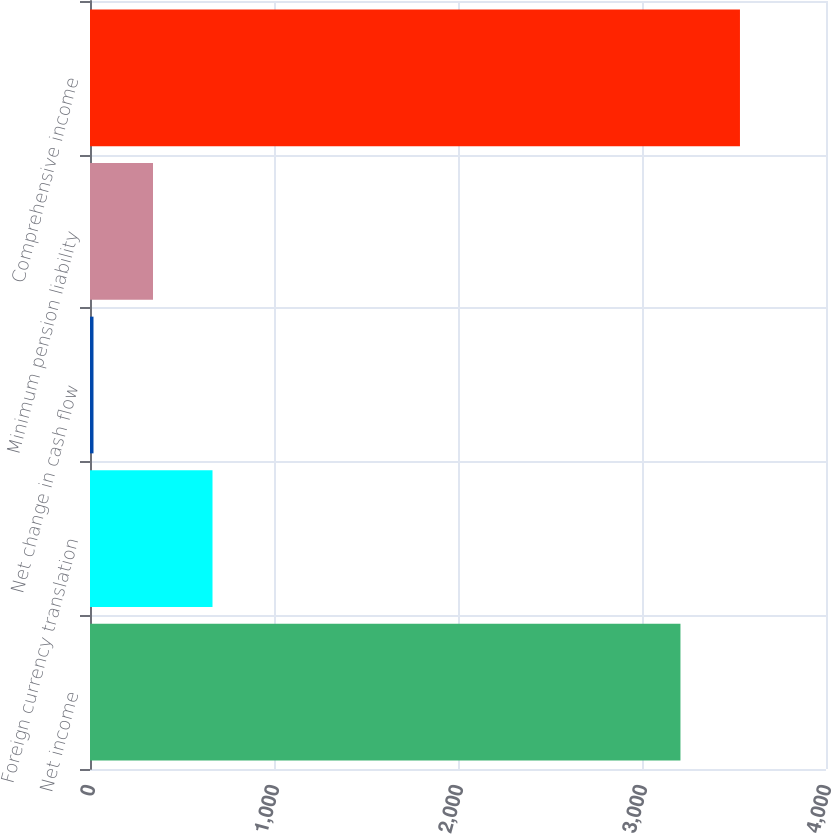Convert chart to OTSL. <chart><loc_0><loc_0><loc_500><loc_500><bar_chart><fcel>Net income<fcel>Foreign currency translation<fcel>Net change in cash flow<fcel>Minimum pension liability<fcel>Comprehensive income<nl><fcel>3209<fcel>665.8<fcel>19<fcel>342.4<fcel>3532.4<nl></chart> 